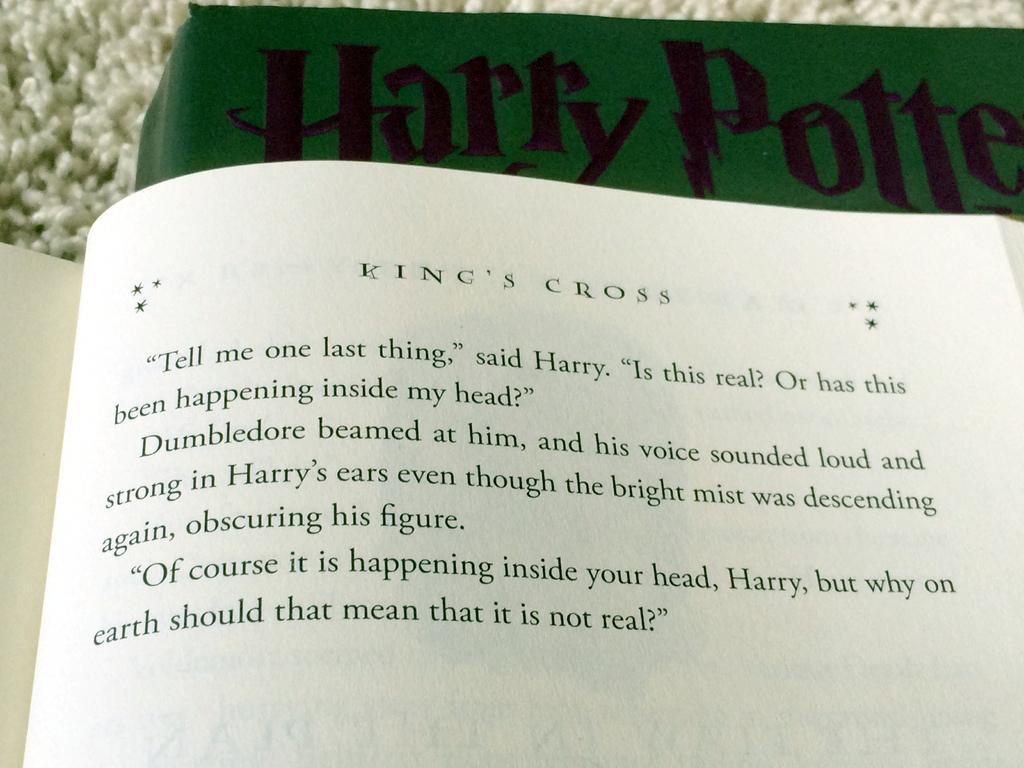Please provide a concise description of this image. In the picture we can see a book page which is opened and in it we can see some information and behind it, we can see another book which is green in color and name on it is Harry Potter. 